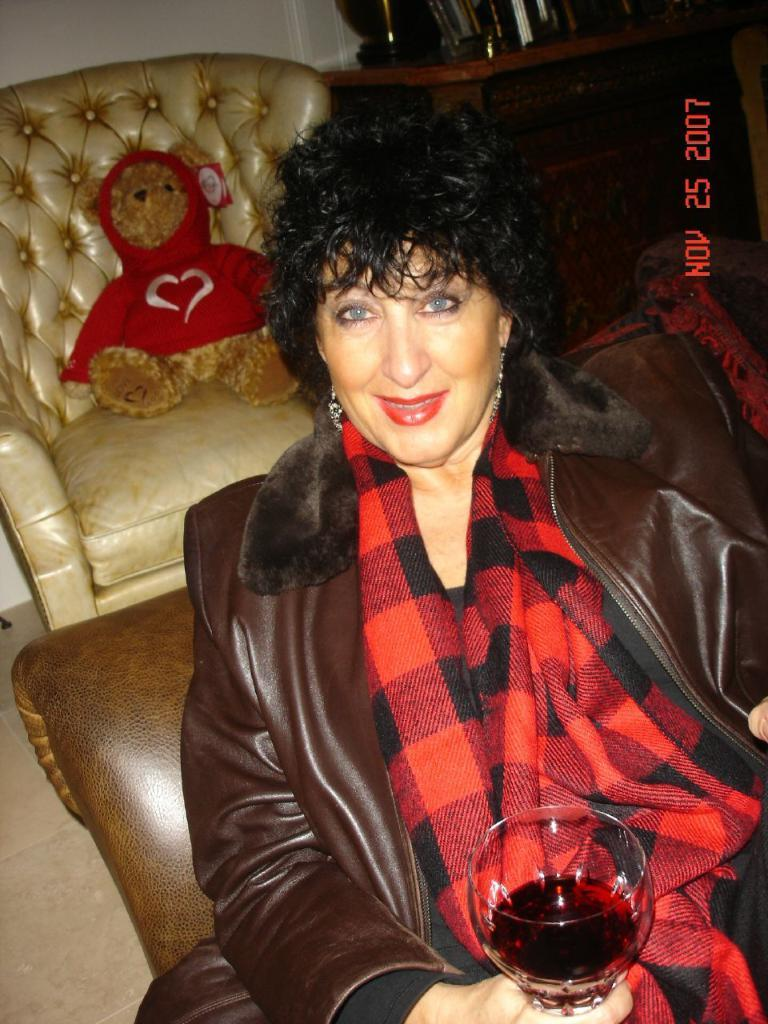What is the person in the image doing? The person is sitting on a chair in the image. What is the person holding in the image? The person is holding a glass. How many chairs are visible in the image? There are chairs in the image. What is placed on one of the chairs? There is a doll on one of the chairs. What can be seen in the background of the image? There is a wall visible in the background of the image. What is the person's reaction to the sky in the image? There is no sky visible in the image, so it is not possible to determine the person's reaction to it. 